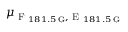<formula> <loc_0><loc_0><loc_500><loc_500>\mu _ { F _ { 1 8 1 . 5 \, G } , E _ { 1 8 1 . 5 \, G } }</formula> 